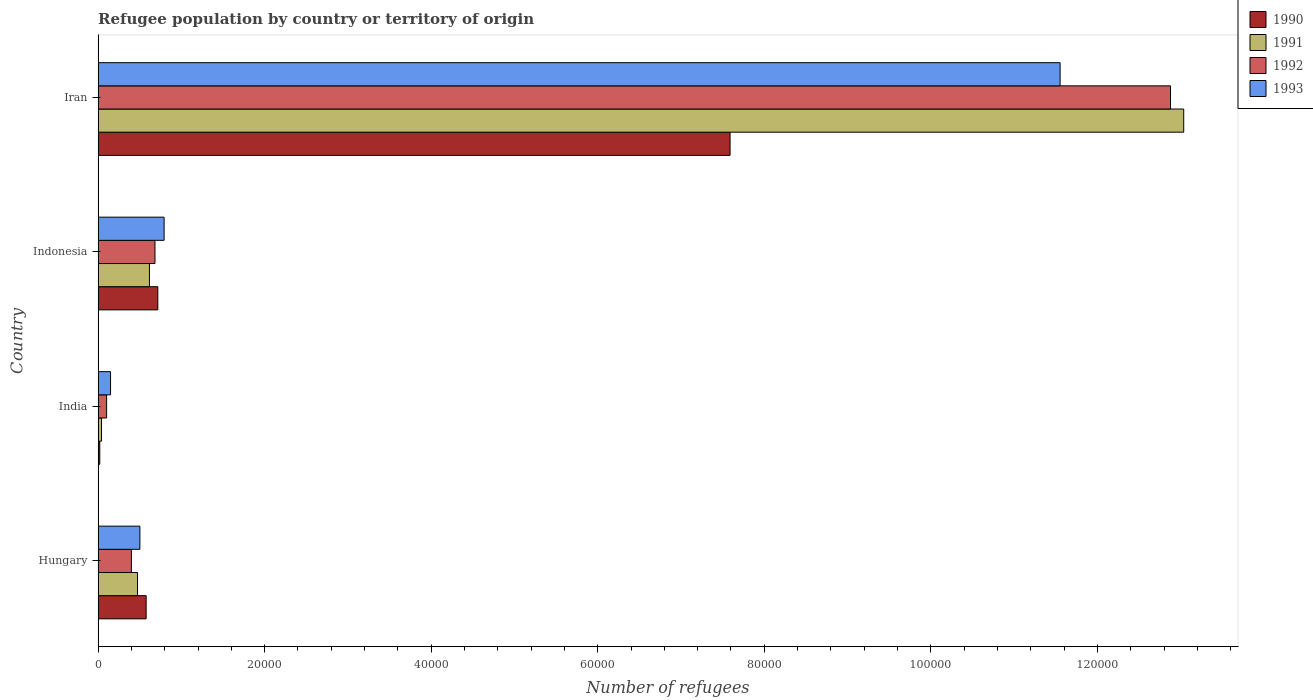How many different coloured bars are there?
Provide a succinct answer. 4. How many groups of bars are there?
Your answer should be compact. 4. Are the number of bars per tick equal to the number of legend labels?
Give a very brief answer. Yes. Are the number of bars on each tick of the Y-axis equal?
Your response must be concise. Yes. How many bars are there on the 2nd tick from the bottom?
Make the answer very short. 4. What is the label of the 4th group of bars from the top?
Your response must be concise. Hungary. In how many cases, is the number of bars for a given country not equal to the number of legend labels?
Offer a very short reply. 0. What is the number of refugees in 1993 in India?
Keep it short and to the point. 1492. Across all countries, what is the maximum number of refugees in 1992?
Your response must be concise. 1.29e+05. Across all countries, what is the minimum number of refugees in 1993?
Your answer should be very brief. 1492. In which country was the number of refugees in 1990 maximum?
Give a very brief answer. Iran. In which country was the number of refugees in 1992 minimum?
Provide a short and direct response. India. What is the total number of refugees in 1990 in the graph?
Make the answer very short. 8.90e+04. What is the difference between the number of refugees in 1990 in Hungary and that in Iran?
Provide a short and direct response. -7.01e+04. What is the difference between the number of refugees in 1992 in Iran and the number of refugees in 1991 in Indonesia?
Offer a terse response. 1.23e+05. What is the average number of refugees in 1990 per country?
Ensure brevity in your answer.  2.23e+04. What is the difference between the number of refugees in 1993 and number of refugees in 1990 in Iran?
Ensure brevity in your answer.  3.96e+04. What is the ratio of the number of refugees in 1990 in Hungary to that in Indonesia?
Make the answer very short. 0.8. What is the difference between the highest and the second highest number of refugees in 1991?
Your answer should be very brief. 1.24e+05. What is the difference between the highest and the lowest number of refugees in 1990?
Offer a very short reply. 7.57e+04. In how many countries, is the number of refugees in 1993 greater than the average number of refugees in 1993 taken over all countries?
Offer a very short reply. 1. Is it the case that in every country, the sum of the number of refugees in 1992 and number of refugees in 1993 is greater than the sum of number of refugees in 1991 and number of refugees in 1990?
Your answer should be very brief. No. What does the 2nd bar from the bottom in Indonesia represents?
Offer a terse response. 1991. Are all the bars in the graph horizontal?
Offer a terse response. Yes. How many countries are there in the graph?
Offer a very short reply. 4. What is the difference between two consecutive major ticks on the X-axis?
Ensure brevity in your answer.  2.00e+04. Does the graph contain any zero values?
Your answer should be very brief. No. Does the graph contain grids?
Provide a short and direct response. No. How many legend labels are there?
Your answer should be compact. 4. What is the title of the graph?
Keep it short and to the point. Refugee population by country or territory of origin. What is the label or title of the X-axis?
Offer a very short reply. Number of refugees. What is the label or title of the Y-axis?
Offer a very short reply. Country. What is the Number of refugees of 1990 in Hungary?
Your response must be concise. 5767. What is the Number of refugees of 1991 in Hungary?
Offer a very short reply. 4733. What is the Number of refugees of 1992 in Hungary?
Ensure brevity in your answer.  3993. What is the Number of refugees in 1993 in Hungary?
Give a very brief answer. 5016. What is the Number of refugees in 1990 in India?
Offer a terse response. 198. What is the Number of refugees in 1991 in India?
Offer a terse response. 408. What is the Number of refugees in 1992 in India?
Give a very brief answer. 1019. What is the Number of refugees of 1993 in India?
Your response must be concise. 1492. What is the Number of refugees of 1990 in Indonesia?
Your answer should be compact. 7169. What is the Number of refugees in 1991 in Indonesia?
Ensure brevity in your answer.  6164. What is the Number of refugees of 1992 in Indonesia?
Ensure brevity in your answer.  6829. What is the Number of refugees in 1993 in Indonesia?
Offer a terse response. 7924. What is the Number of refugees in 1990 in Iran?
Give a very brief answer. 7.59e+04. What is the Number of refugees of 1991 in Iran?
Give a very brief answer. 1.30e+05. What is the Number of refugees in 1992 in Iran?
Provide a succinct answer. 1.29e+05. What is the Number of refugees in 1993 in Iran?
Offer a terse response. 1.16e+05. Across all countries, what is the maximum Number of refugees of 1990?
Keep it short and to the point. 7.59e+04. Across all countries, what is the maximum Number of refugees in 1991?
Your response must be concise. 1.30e+05. Across all countries, what is the maximum Number of refugees of 1992?
Your response must be concise. 1.29e+05. Across all countries, what is the maximum Number of refugees of 1993?
Offer a terse response. 1.16e+05. Across all countries, what is the minimum Number of refugees of 1990?
Ensure brevity in your answer.  198. Across all countries, what is the minimum Number of refugees of 1991?
Provide a succinct answer. 408. Across all countries, what is the minimum Number of refugees in 1992?
Offer a terse response. 1019. Across all countries, what is the minimum Number of refugees in 1993?
Your answer should be compact. 1492. What is the total Number of refugees of 1990 in the graph?
Your answer should be very brief. 8.90e+04. What is the total Number of refugees in 1991 in the graph?
Provide a short and direct response. 1.42e+05. What is the total Number of refugees in 1992 in the graph?
Give a very brief answer. 1.41e+05. What is the total Number of refugees of 1993 in the graph?
Ensure brevity in your answer.  1.30e+05. What is the difference between the Number of refugees of 1990 in Hungary and that in India?
Your response must be concise. 5569. What is the difference between the Number of refugees of 1991 in Hungary and that in India?
Provide a short and direct response. 4325. What is the difference between the Number of refugees in 1992 in Hungary and that in India?
Give a very brief answer. 2974. What is the difference between the Number of refugees in 1993 in Hungary and that in India?
Your answer should be compact. 3524. What is the difference between the Number of refugees of 1990 in Hungary and that in Indonesia?
Keep it short and to the point. -1402. What is the difference between the Number of refugees in 1991 in Hungary and that in Indonesia?
Give a very brief answer. -1431. What is the difference between the Number of refugees in 1992 in Hungary and that in Indonesia?
Make the answer very short. -2836. What is the difference between the Number of refugees in 1993 in Hungary and that in Indonesia?
Ensure brevity in your answer.  -2908. What is the difference between the Number of refugees in 1990 in Hungary and that in Iran?
Your answer should be compact. -7.01e+04. What is the difference between the Number of refugees in 1991 in Hungary and that in Iran?
Offer a very short reply. -1.26e+05. What is the difference between the Number of refugees in 1992 in Hungary and that in Iran?
Ensure brevity in your answer.  -1.25e+05. What is the difference between the Number of refugees in 1993 in Hungary and that in Iran?
Your answer should be compact. -1.11e+05. What is the difference between the Number of refugees of 1990 in India and that in Indonesia?
Provide a succinct answer. -6971. What is the difference between the Number of refugees in 1991 in India and that in Indonesia?
Provide a succinct answer. -5756. What is the difference between the Number of refugees in 1992 in India and that in Indonesia?
Your answer should be very brief. -5810. What is the difference between the Number of refugees in 1993 in India and that in Indonesia?
Your answer should be compact. -6432. What is the difference between the Number of refugees of 1990 in India and that in Iran?
Give a very brief answer. -7.57e+04. What is the difference between the Number of refugees in 1991 in India and that in Iran?
Your answer should be compact. -1.30e+05. What is the difference between the Number of refugees in 1992 in India and that in Iran?
Provide a succinct answer. -1.28e+05. What is the difference between the Number of refugees of 1993 in India and that in Iran?
Offer a terse response. -1.14e+05. What is the difference between the Number of refugees of 1990 in Indonesia and that in Iran?
Your response must be concise. -6.87e+04. What is the difference between the Number of refugees of 1991 in Indonesia and that in Iran?
Ensure brevity in your answer.  -1.24e+05. What is the difference between the Number of refugees of 1992 in Indonesia and that in Iran?
Make the answer very short. -1.22e+05. What is the difference between the Number of refugees of 1993 in Indonesia and that in Iran?
Make the answer very short. -1.08e+05. What is the difference between the Number of refugees of 1990 in Hungary and the Number of refugees of 1991 in India?
Make the answer very short. 5359. What is the difference between the Number of refugees in 1990 in Hungary and the Number of refugees in 1992 in India?
Give a very brief answer. 4748. What is the difference between the Number of refugees of 1990 in Hungary and the Number of refugees of 1993 in India?
Provide a short and direct response. 4275. What is the difference between the Number of refugees in 1991 in Hungary and the Number of refugees in 1992 in India?
Offer a terse response. 3714. What is the difference between the Number of refugees in 1991 in Hungary and the Number of refugees in 1993 in India?
Keep it short and to the point. 3241. What is the difference between the Number of refugees in 1992 in Hungary and the Number of refugees in 1993 in India?
Ensure brevity in your answer.  2501. What is the difference between the Number of refugees of 1990 in Hungary and the Number of refugees of 1991 in Indonesia?
Offer a very short reply. -397. What is the difference between the Number of refugees of 1990 in Hungary and the Number of refugees of 1992 in Indonesia?
Provide a succinct answer. -1062. What is the difference between the Number of refugees of 1990 in Hungary and the Number of refugees of 1993 in Indonesia?
Your answer should be compact. -2157. What is the difference between the Number of refugees in 1991 in Hungary and the Number of refugees in 1992 in Indonesia?
Keep it short and to the point. -2096. What is the difference between the Number of refugees in 1991 in Hungary and the Number of refugees in 1993 in Indonesia?
Make the answer very short. -3191. What is the difference between the Number of refugees in 1992 in Hungary and the Number of refugees in 1993 in Indonesia?
Provide a short and direct response. -3931. What is the difference between the Number of refugees in 1990 in Hungary and the Number of refugees in 1991 in Iran?
Give a very brief answer. -1.25e+05. What is the difference between the Number of refugees in 1990 in Hungary and the Number of refugees in 1992 in Iran?
Offer a very short reply. -1.23e+05. What is the difference between the Number of refugees in 1990 in Hungary and the Number of refugees in 1993 in Iran?
Offer a very short reply. -1.10e+05. What is the difference between the Number of refugees of 1991 in Hungary and the Number of refugees of 1992 in Iran?
Your answer should be compact. -1.24e+05. What is the difference between the Number of refugees in 1991 in Hungary and the Number of refugees in 1993 in Iran?
Offer a very short reply. -1.11e+05. What is the difference between the Number of refugees in 1992 in Hungary and the Number of refugees in 1993 in Iran?
Provide a succinct answer. -1.12e+05. What is the difference between the Number of refugees of 1990 in India and the Number of refugees of 1991 in Indonesia?
Ensure brevity in your answer.  -5966. What is the difference between the Number of refugees of 1990 in India and the Number of refugees of 1992 in Indonesia?
Make the answer very short. -6631. What is the difference between the Number of refugees of 1990 in India and the Number of refugees of 1993 in Indonesia?
Offer a very short reply. -7726. What is the difference between the Number of refugees of 1991 in India and the Number of refugees of 1992 in Indonesia?
Keep it short and to the point. -6421. What is the difference between the Number of refugees of 1991 in India and the Number of refugees of 1993 in Indonesia?
Provide a short and direct response. -7516. What is the difference between the Number of refugees in 1992 in India and the Number of refugees in 1993 in Indonesia?
Make the answer very short. -6905. What is the difference between the Number of refugees of 1990 in India and the Number of refugees of 1991 in Iran?
Make the answer very short. -1.30e+05. What is the difference between the Number of refugees of 1990 in India and the Number of refugees of 1992 in Iran?
Keep it short and to the point. -1.29e+05. What is the difference between the Number of refugees of 1990 in India and the Number of refugees of 1993 in Iran?
Your response must be concise. -1.15e+05. What is the difference between the Number of refugees of 1991 in India and the Number of refugees of 1992 in Iran?
Provide a succinct answer. -1.28e+05. What is the difference between the Number of refugees in 1991 in India and the Number of refugees in 1993 in Iran?
Provide a short and direct response. -1.15e+05. What is the difference between the Number of refugees in 1992 in India and the Number of refugees in 1993 in Iran?
Provide a short and direct response. -1.15e+05. What is the difference between the Number of refugees of 1990 in Indonesia and the Number of refugees of 1991 in Iran?
Give a very brief answer. -1.23e+05. What is the difference between the Number of refugees in 1990 in Indonesia and the Number of refugees in 1992 in Iran?
Make the answer very short. -1.22e+05. What is the difference between the Number of refugees of 1990 in Indonesia and the Number of refugees of 1993 in Iran?
Ensure brevity in your answer.  -1.08e+05. What is the difference between the Number of refugees in 1991 in Indonesia and the Number of refugees in 1992 in Iran?
Ensure brevity in your answer.  -1.23e+05. What is the difference between the Number of refugees of 1991 in Indonesia and the Number of refugees of 1993 in Iran?
Ensure brevity in your answer.  -1.09e+05. What is the difference between the Number of refugees of 1992 in Indonesia and the Number of refugees of 1993 in Iran?
Keep it short and to the point. -1.09e+05. What is the average Number of refugees of 1990 per country?
Offer a very short reply. 2.23e+04. What is the average Number of refugees in 1991 per country?
Your answer should be compact. 3.54e+04. What is the average Number of refugees of 1992 per country?
Make the answer very short. 3.52e+04. What is the average Number of refugees of 1993 per country?
Your response must be concise. 3.25e+04. What is the difference between the Number of refugees in 1990 and Number of refugees in 1991 in Hungary?
Give a very brief answer. 1034. What is the difference between the Number of refugees of 1990 and Number of refugees of 1992 in Hungary?
Your answer should be very brief. 1774. What is the difference between the Number of refugees of 1990 and Number of refugees of 1993 in Hungary?
Ensure brevity in your answer.  751. What is the difference between the Number of refugees in 1991 and Number of refugees in 1992 in Hungary?
Your response must be concise. 740. What is the difference between the Number of refugees of 1991 and Number of refugees of 1993 in Hungary?
Your response must be concise. -283. What is the difference between the Number of refugees of 1992 and Number of refugees of 1993 in Hungary?
Ensure brevity in your answer.  -1023. What is the difference between the Number of refugees in 1990 and Number of refugees in 1991 in India?
Offer a terse response. -210. What is the difference between the Number of refugees of 1990 and Number of refugees of 1992 in India?
Your answer should be very brief. -821. What is the difference between the Number of refugees of 1990 and Number of refugees of 1993 in India?
Your response must be concise. -1294. What is the difference between the Number of refugees of 1991 and Number of refugees of 1992 in India?
Your answer should be very brief. -611. What is the difference between the Number of refugees of 1991 and Number of refugees of 1993 in India?
Provide a succinct answer. -1084. What is the difference between the Number of refugees in 1992 and Number of refugees in 1993 in India?
Give a very brief answer. -473. What is the difference between the Number of refugees in 1990 and Number of refugees in 1991 in Indonesia?
Your answer should be very brief. 1005. What is the difference between the Number of refugees in 1990 and Number of refugees in 1992 in Indonesia?
Make the answer very short. 340. What is the difference between the Number of refugees of 1990 and Number of refugees of 1993 in Indonesia?
Your response must be concise. -755. What is the difference between the Number of refugees in 1991 and Number of refugees in 1992 in Indonesia?
Give a very brief answer. -665. What is the difference between the Number of refugees of 1991 and Number of refugees of 1993 in Indonesia?
Offer a terse response. -1760. What is the difference between the Number of refugees of 1992 and Number of refugees of 1993 in Indonesia?
Offer a very short reply. -1095. What is the difference between the Number of refugees of 1990 and Number of refugees of 1991 in Iran?
Keep it short and to the point. -5.45e+04. What is the difference between the Number of refugees of 1990 and Number of refugees of 1992 in Iran?
Your answer should be very brief. -5.29e+04. What is the difference between the Number of refugees of 1990 and Number of refugees of 1993 in Iran?
Keep it short and to the point. -3.96e+04. What is the difference between the Number of refugees of 1991 and Number of refugees of 1992 in Iran?
Your answer should be very brief. 1585. What is the difference between the Number of refugees of 1991 and Number of refugees of 1993 in Iran?
Your response must be concise. 1.48e+04. What is the difference between the Number of refugees in 1992 and Number of refugees in 1993 in Iran?
Your answer should be compact. 1.33e+04. What is the ratio of the Number of refugees in 1990 in Hungary to that in India?
Your response must be concise. 29.13. What is the ratio of the Number of refugees in 1991 in Hungary to that in India?
Provide a succinct answer. 11.6. What is the ratio of the Number of refugees of 1992 in Hungary to that in India?
Make the answer very short. 3.92. What is the ratio of the Number of refugees in 1993 in Hungary to that in India?
Provide a short and direct response. 3.36. What is the ratio of the Number of refugees of 1990 in Hungary to that in Indonesia?
Your answer should be very brief. 0.8. What is the ratio of the Number of refugees in 1991 in Hungary to that in Indonesia?
Your answer should be compact. 0.77. What is the ratio of the Number of refugees of 1992 in Hungary to that in Indonesia?
Ensure brevity in your answer.  0.58. What is the ratio of the Number of refugees of 1993 in Hungary to that in Indonesia?
Your answer should be very brief. 0.63. What is the ratio of the Number of refugees in 1990 in Hungary to that in Iran?
Your answer should be very brief. 0.08. What is the ratio of the Number of refugees in 1991 in Hungary to that in Iran?
Provide a short and direct response. 0.04. What is the ratio of the Number of refugees in 1992 in Hungary to that in Iran?
Keep it short and to the point. 0.03. What is the ratio of the Number of refugees of 1993 in Hungary to that in Iran?
Your answer should be compact. 0.04. What is the ratio of the Number of refugees in 1990 in India to that in Indonesia?
Make the answer very short. 0.03. What is the ratio of the Number of refugees of 1991 in India to that in Indonesia?
Your answer should be very brief. 0.07. What is the ratio of the Number of refugees in 1992 in India to that in Indonesia?
Make the answer very short. 0.15. What is the ratio of the Number of refugees in 1993 in India to that in Indonesia?
Your response must be concise. 0.19. What is the ratio of the Number of refugees in 1990 in India to that in Iran?
Your answer should be very brief. 0. What is the ratio of the Number of refugees in 1991 in India to that in Iran?
Keep it short and to the point. 0. What is the ratio of the Number of refugees of 1992 in India to that in Iran?
Offer a very short reply. 0.01. What is the ratio of the Number of refugees of 1993 in India to that in Iran?
Keep it short and to the point. 0.01. What is the ratio of the Number of refugees in 1990 in Indonesia to that in Iran?
Provide a succinct answer. 0.09. What is the ratio of the Number of refugees in 1991 in Indonesia to that in Iran?
Ensure brevity in your answer.  0.05. What is the ratio of the Number of refugees of 1992 in Indonesia to that in Iran?
Your response must be concise. 0.05. What is the ratio of the Number of refugees of 1993 in Indonesia to that in Iran?
Give a very brief answer. 0.07. What is the difference between the highest and the second highest Number of refugees of 1990?
Your answer should be compact. 6.87e+04. What is the difference between the highest and the second highest Number of refugees of 1991?
Offer a terse response. 1.24e+05. What is the difference between the highest and the second highest Number of refugees of 1992?
Keep it short and to the point. 1.22e+05. What is the difference between the highest and the second highest Number of refugees of 1993?
Offer a terse response. 1.08e+05. What is the difference between the highest and the lowest Number of refugees in 1990?
Your answer should be compact. 7.57e+04. What is the difference between the highest and the lowest Number of refugees of 1991?
Your response must be concise. 1.30e+05. What is the difference between the highest and the lowest Number of refugees in 1992?
Offer a very short reply. 1.28e+05. What is the difference between the highest and the lowest Number of refugees of 1993?
Your response must be concise. 1.14e+05. 